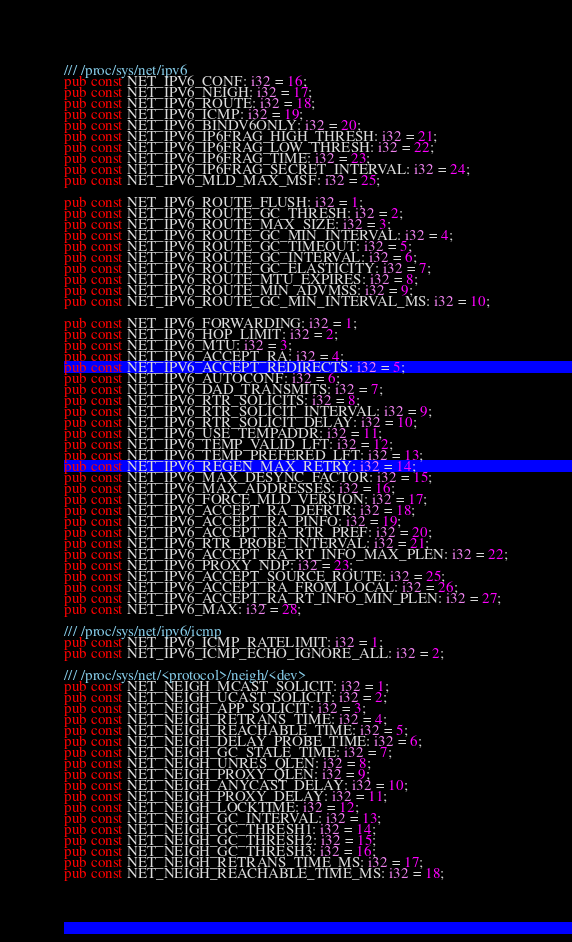Convert code to text. <code><loc_0><loc_0><loc_500><loc_500><_Rust_>/// /proc/sys/net/ipv6
pub const NET_IPV6_CONF: i32 = 16;
pub const NET_IPV6_NEIGH: i32 = 17;
pub const NET_IPV6_ROUTE: i32 = 18;
pub const NET_IPV6_ICMP: i32 = 19;
pub const NET_IPV6_BINDV6ONLY: i32 = 20;
pub const NET_IPV6_IP6FRAG_HIGH_THRESH: i32 = 21;
pub const NET_IPV6_IP6FRAG_LOW_THRESH: i32 = 22;
pub const NET_IPV6_IP6FRAG_TIME: i32 = 23;
pub const NET_IPV6_IP6FRAG_SECRET_INTERVAL: i32 = 24;
pub const NET_IPV6_MLD_MAX_MSF: i32 = 25;

pub const NET_IPV6_ROUTE_FLUSH: i32 = 1;
pub const NET_IPV6_ROUTE_GC_THRESH: i32 = 2;
pub const NET_IPV6_ROUTE_MAX_SIZE: i32 = 3;
pub const NET_IPV6_ROUTE_GC_MIN_INTERVAL: i32 = 4;
pub const NET_IPV6_ROUTE_GC_TIMEOUT: i32 = 5;
pub const NET_IPV6_ROUTE_GC_INTERVAL: i32 = 6;
pub const NET_IPV6_ROUTE_GC_ELASTICITY: i32 = 7;
pub const NET_IPV6_ROUTE_MTU_EXPIRES: i32 = 8;
pub const NET_IPV6_ROUTE_MIN_ADVMSS: i32 = 9;
pub const NET_IPV6_ROUTE_GC_MIN_INTERVAL_MS: i32 = 10;

pub const NET_IPV6_FORWARDING: i32 = 1;
pub const NET_IPV6_HOP_LIMIT: i32 = 2;
pub const NET_IPV6_MTU: i32 = 3;
pub const NET_IPV6_ACCEPT_RA: i32 = 4;
pub const NET_IPV6_ACCEPT_REDIRECTS: i32 = 5;
pub const NET_IPV6_AUTOCONF: i32 = 6;
pub const NET_IPV6_DAD_TRANSMITS: i32 = 7;
pub const NET_IPV6_RTR_SOLICITS: i32 = 8;
pub const NET_IPV6_RTR_SOLICIT_INTERVAL: i32 = 9;
pub const NET_IPV6_RTR_SOLICIT_DELAY: i32 = 10;
pub const NET_IPV6_USE_TEMPADDR: i32 = 11;
pub const NET_IPV6_TEMP_VALID_LFT: i32 = 12;
pub const NET_IPV6_TEMP_PREFERED_LFT: i32 = 13;
pub const NET_IPV6_REGEN_MAX_RETRY: i32 = 14;
pub const NET_IPV6_MAX_DESYNC_FACTOR: i32 = 15;
pub const NET_IPV6_MAX_ADDRESSES: i32 = 16;
pub const NET_IPV6_FORCE_MLD_VERSION: i32 = 17;
pub const NET_IPV6_ACCEPT_RA_DEFRTR: i32 = 18;
pub const NET_IPV6_ACCEPT_RA_PINFO: i32 = 19;
pub const NET_IPV6_ACCEPT_RA_RTR_PREF: i32 = 20;
pub const NET_IPV6_RTR_PROBE_INTERVAL: i32 = 21;
pub const NET_IPV6_ACCEPT_RA_RT_INFO_MAX_PLEN: i32 = 22;
pub const NET_IPV6_PROXY_NDP: i32 = 23;
pub const NET_IPV6_ACCEPT_SOURCE_ROUTE: i32 = 25;
pub const NET_IPV6_ACCEPT_RA_FROM_LOCAL: i32 = 26;
pub const NET_IPV6_ACCEPT_RA_RT_INFO_MIN_PLEN: i32 = 27;
pub const NET_IPV6_MAX: i32 = 28;

/// /proc/sys/net/ipv6/icmp
pub const NET_IPV6_ICMP_RATELIMIT: i32 = 1;
pub const NET_IPV6_ICMP_ECHO_IGNORE_ALL: i32 = 2;

/// /proc/sys/net/<protocol>/neigh/<dev>
pub const NET_NEIGH_MCAST_SOLICIT: i32 = 1;
pub const NET_NEIGH_UCAST_SOLICIT: i32 = 2;
pub const NET_NEIGH_APP_SOLICIT: i32 = 3;
pub const NET_NEIGH_RETRANS_TIME: i32 = 4;
pub const NET_NEIGH_REACHABLE_TIME: i32 = 5;
pub const NET_NEIGH_DELAY_PROBE_TIME: i32 = 6;
pub const NET_NEIGH_GC_STALE_TIME: i32 = 7;
pub const NET_NEIGH_UNRES_QLEN: i32 = 8;
pub const NET_NEIGH_PROXY_QLEN: i32 = 9;
pub const NET_NEIGH_ANYCAST_DELAY: i32 = 10;
pub const NET_NEIGH_PROXY_DELAY: i32 = 11;
pub const NET_NEIGH_LOCKTIME: i32 = 12;
pub const NET_NEIGH_GC_INTERVAL: i32 = 13;
pub const NET_NEIGH_GC_THRESH1: i32 = 14;
pub const NET_NEIGH_GC_THRESH2: i32 = 15;
pub const NET_NEIGH_GC_THRESH3: i32 = 16;
pub const NET_NEIGH_RETRANS_TIME_MS: i32 = 17;
pub const NET_NEIGH_REACHABLE_TIME_MS: i32 = 18;
</code> 